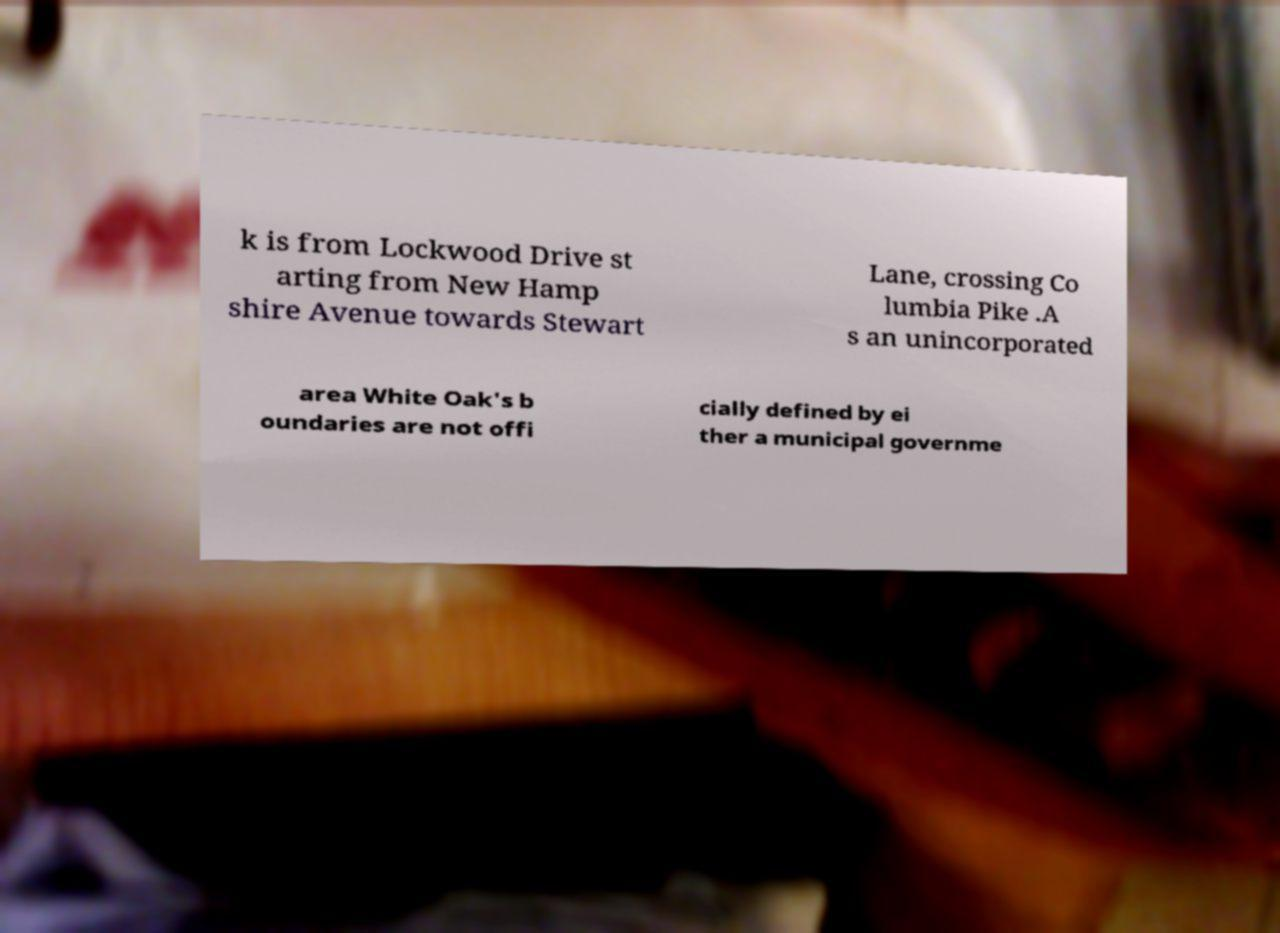Please identify and transcribe the text found in this image. k is from Lockwood Drive st arting from New Hamp shire Avenue towards Stewart Lane, crossing Co lumbia Pike .A s an unincorporated area White Oak's b oundaries are not offi cially defined by ei ther a municipal governme 